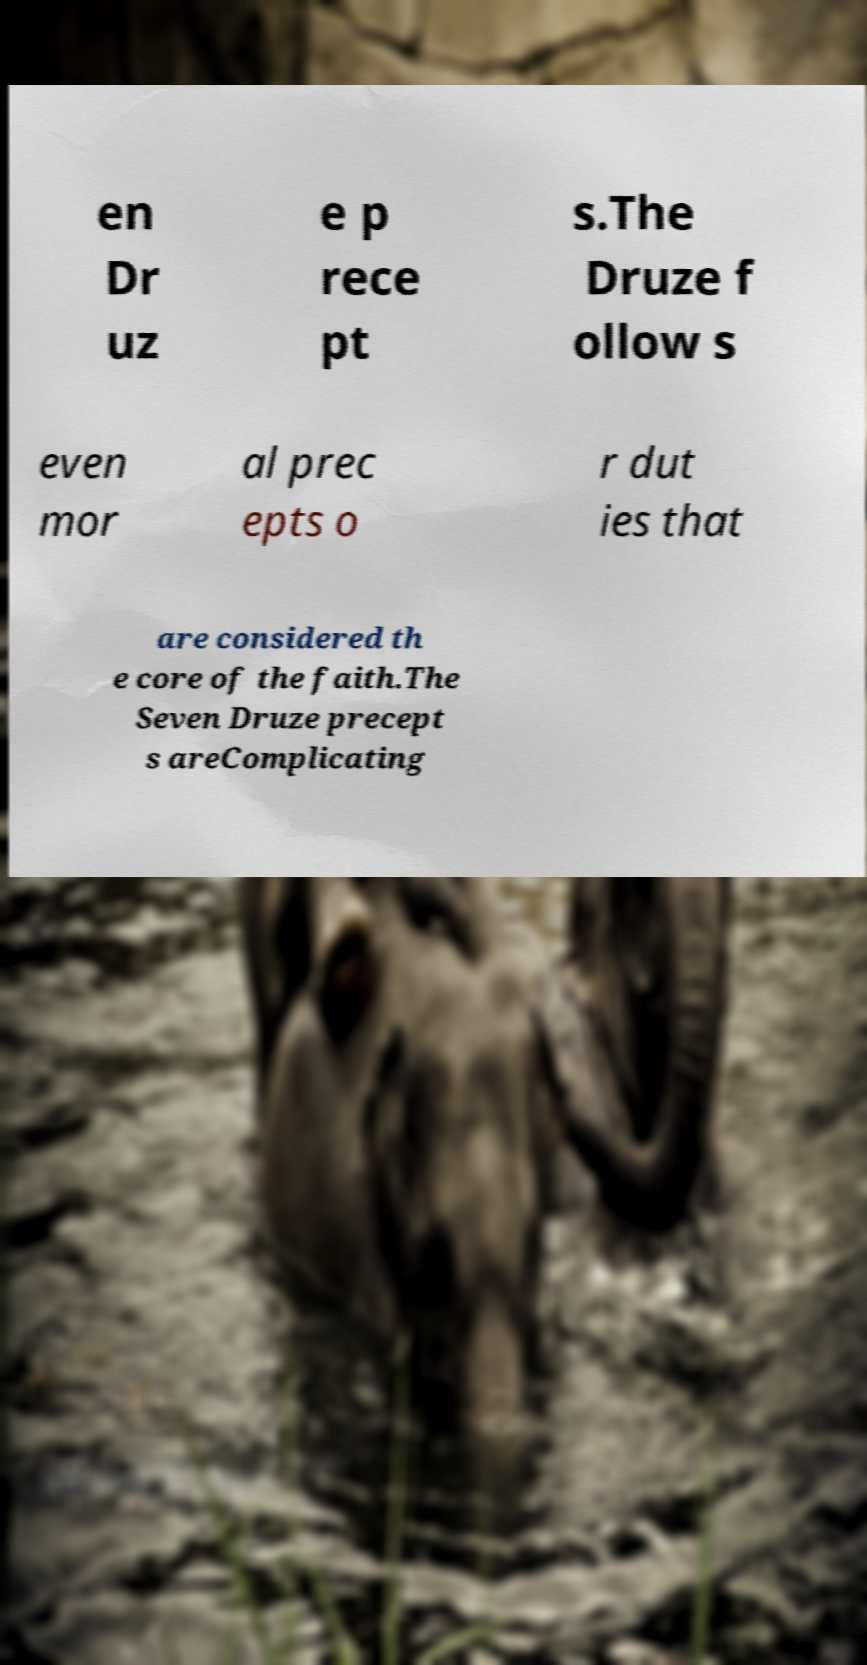What messages or text are displayed in this image? I need them in a readable, typed format. en Dr uz e p rece pt s.The Druze f ollow s even mor al prec epts o r dut ies that are considered th e core of the faith.The Seven Druze precept s areComplicating 